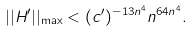<formula> <loc_0><loc_0><loc_500><loc_500>| | H ^ { \prime } | | _ { \max } < ( c ^ { \prime } ) ^ { - 1 3 n ^ { 4 } } n ^ { 6 4 n ^ { 4 } } .</formula> 